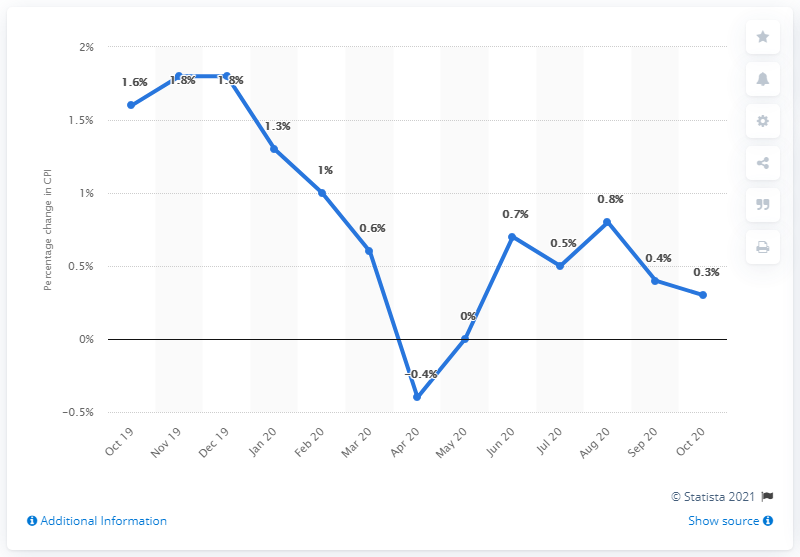Indicate a few pertinent items in this graphic. In October 2020, the Consumer Price Index inflation rate in Sweden was 0.3%. The inflation rate in April 2020 was 0.4%. The sum of mode and the least coefficient of performance (CPI) is 1.4. In October 2019, the consumer price index (CPI) was 1.6. 